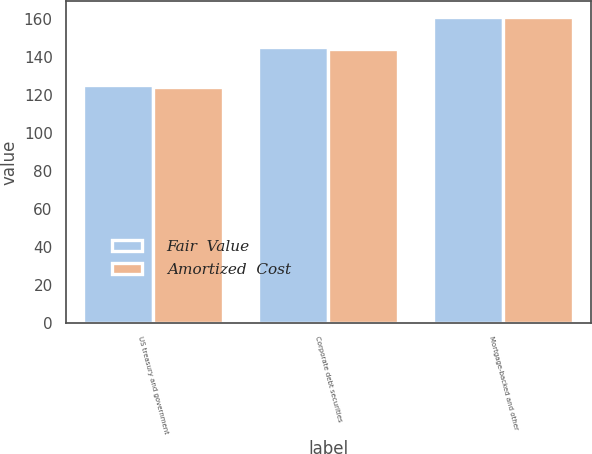Convert chart to OTSL. <chart><loc_0><loc_0><loc_500><loc_500><stacked_bar_chart><ecel><fcel>US treasury and government<fcel>Corporate debt securities<fcel>Mortgage-backed and other<nl><fcel>Fair  Value<fcel>125<fcel>145<fcel>161<nl><fcel>Amortized  Cost<fcel>124<fcel>144<fcel>161<nl></chart> 